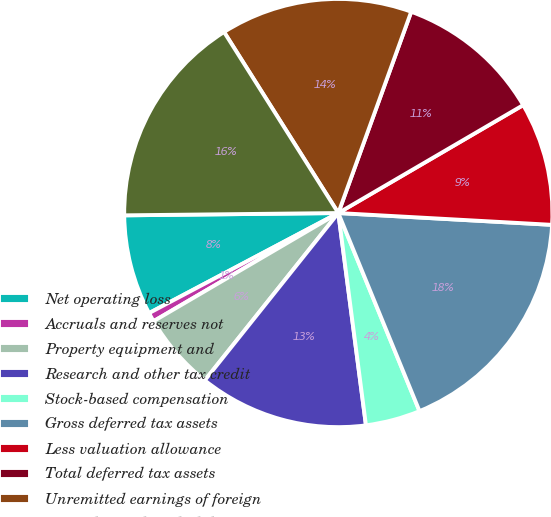Convert chart. <chart><loc_0><loc_0><loc_500><loc_500><pie_chart><fcel>Net operating loss<fcel>Accruals and reserves not<fcel>Property equipment and<fcel>Research and other tax credit<fcel>Stock-based compensation<fcel>Gross deferred tax assets<fcel>Less valuation allowance<fcel>Total deferred tax assets<fcel>Unremitted earnings of foreign<fcel>Gross deferred tax liabilities<nl><fcel>7.57%<fcel>0.69%<fcel>5.85%<fcel>12.78%<fcel>4.13%<fcel>17.93%<fcel>9.29%<fcel>11.06%<fcel>14.49%<fcel>16.21%<nl></chart> 